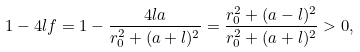Convert formula to latex. <formula><loc_0><loc_0><loc_500><loc_500>1 - 4 l f = 1 - \frac { 4 l a } { r _ { 0 } ^ { 2 } + ( a + l ) ^ { 2 } } = \frac { r ^ { 2 } _ { 0 } + ( a - l ) ^ { 2 } } { r _ { 0 } ^ { 2 } + ( a + l ) ^ { 2 } } > 0 ,</formula> 